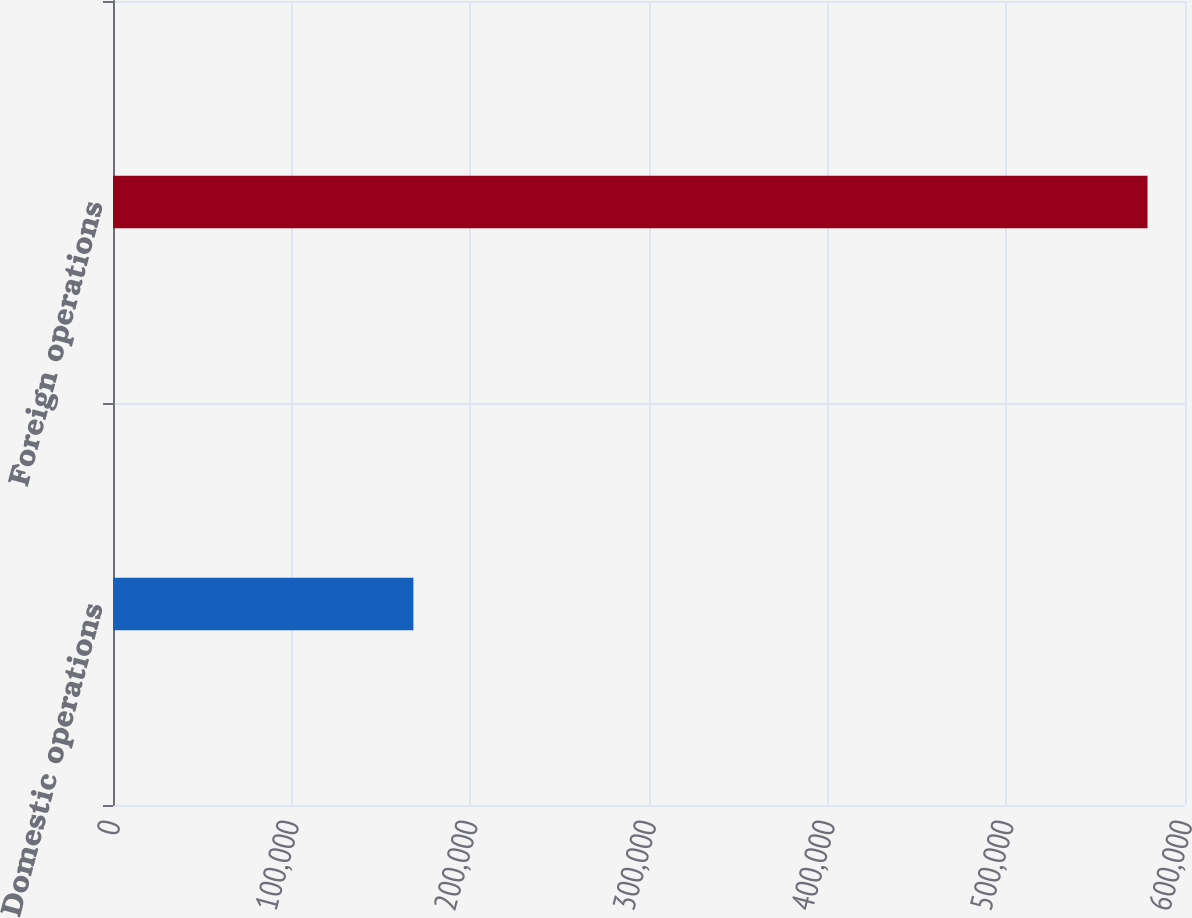<chart> <loc_0><loc_0><loc_500><loc_500><bar_chart><fcel>Domestic operations<fcel>Foreign operations<nl><fcel>168135<fcel>579021<nl></chart> 